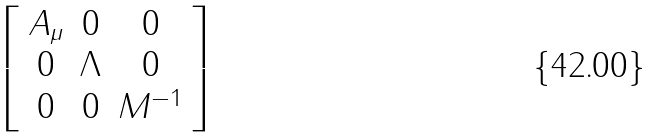<formula> <loc_0><loc_0><loc_500><loc_500>\left [ \begin{array} { c c c } A _ { \mu } & 0 & 0 \\ 0 & \Lambda & 0 \\ 0 & 0 & M ^ { - 1 } \end{array} \right ]</formula> 